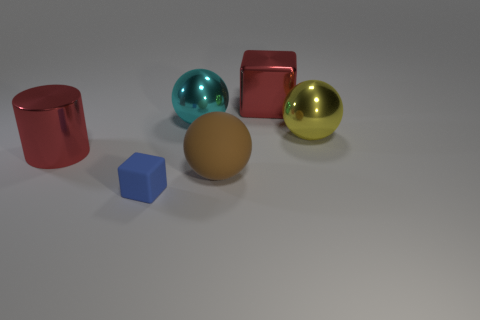Add 2 big brown cylinders. How many objects exist? 8 Subtract all cylinders. How many objects are left? 5 Subtract 0 brown cylinders. How many objects are left? 6 Subtract all big yellow shiny balls. Subtract all matte blocks. How many objects are left? 4 Add 4 small blue blocks. How many small blue blocks are left? 5 Add 3 large red matte cylinders. How many large red matte cylinders exist? 3 